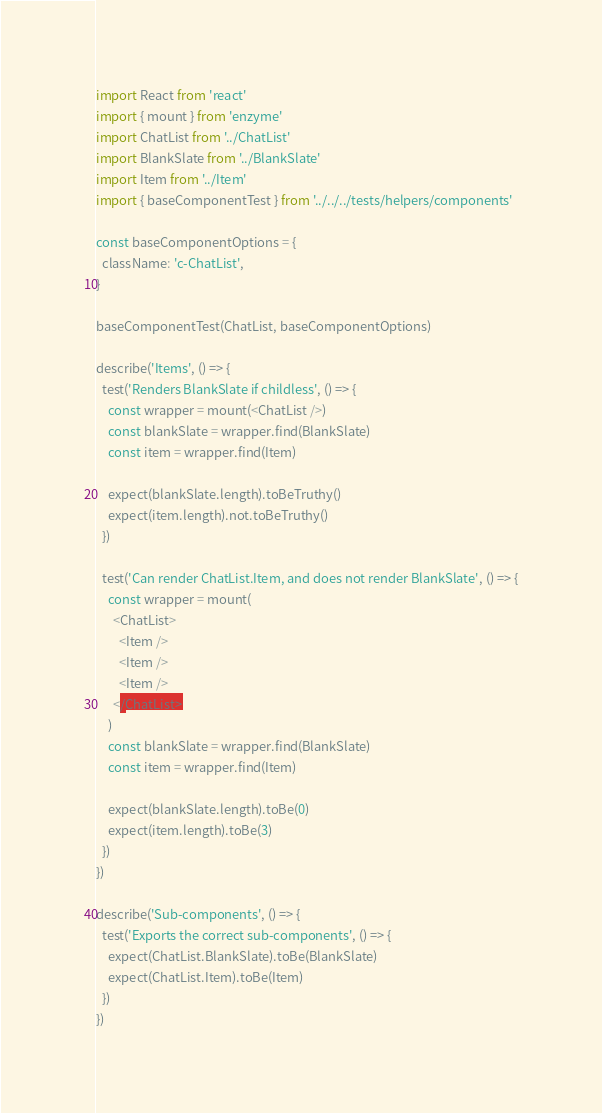<code> <loc_0><loc_0><loc_500><loc_500><_JavaScript_>import React from 'react'
import { mount } from 'enzyme'
import ChatList from '../ChatList'
import BlankSlate from '../BlankSlate'
import Item from '../Item'
import { baseComponentTest } from '../../../tests/helpers/components'

const baseComponentOptions = {
  className: 'c-ChatList',
}

baseComponentTest(ChatList, baseComponentOptions)

describe('Items', () => {
  test('Renders BlankSlate if childless', () => {
    const wrapper = mount(<ChatList />)
    const blankSlate = wrapper.find(BlankSlate)
    const item = wrapper.find(Item)

    expect(blankSlate.length).toBeTruthy()
    expect(item.length).not.toBeTruthy()
  })

  test('Can render ChatList.Item, and does not render BlankSlate', () => {
    const wrapper = mount(
      <ChatList>
        <Item />
        <Item />
        <Item />
      </ChatList>
    )
    const blankSlate = wrapper.find(BlankSlate)
    const item = wrapper.find(Item)

    expect(blankSlate.length).toBe(0)
    expect(item.length).toBe(3)
  })
})

describe('Sub-components', () => {
  test('Exports the correct sub-components', () => {
    expect(ChatList.BlankSlate).toBe(BlankSlate)
    expect(ChatList.Item).toBe(Item)
  })
})
</code> 